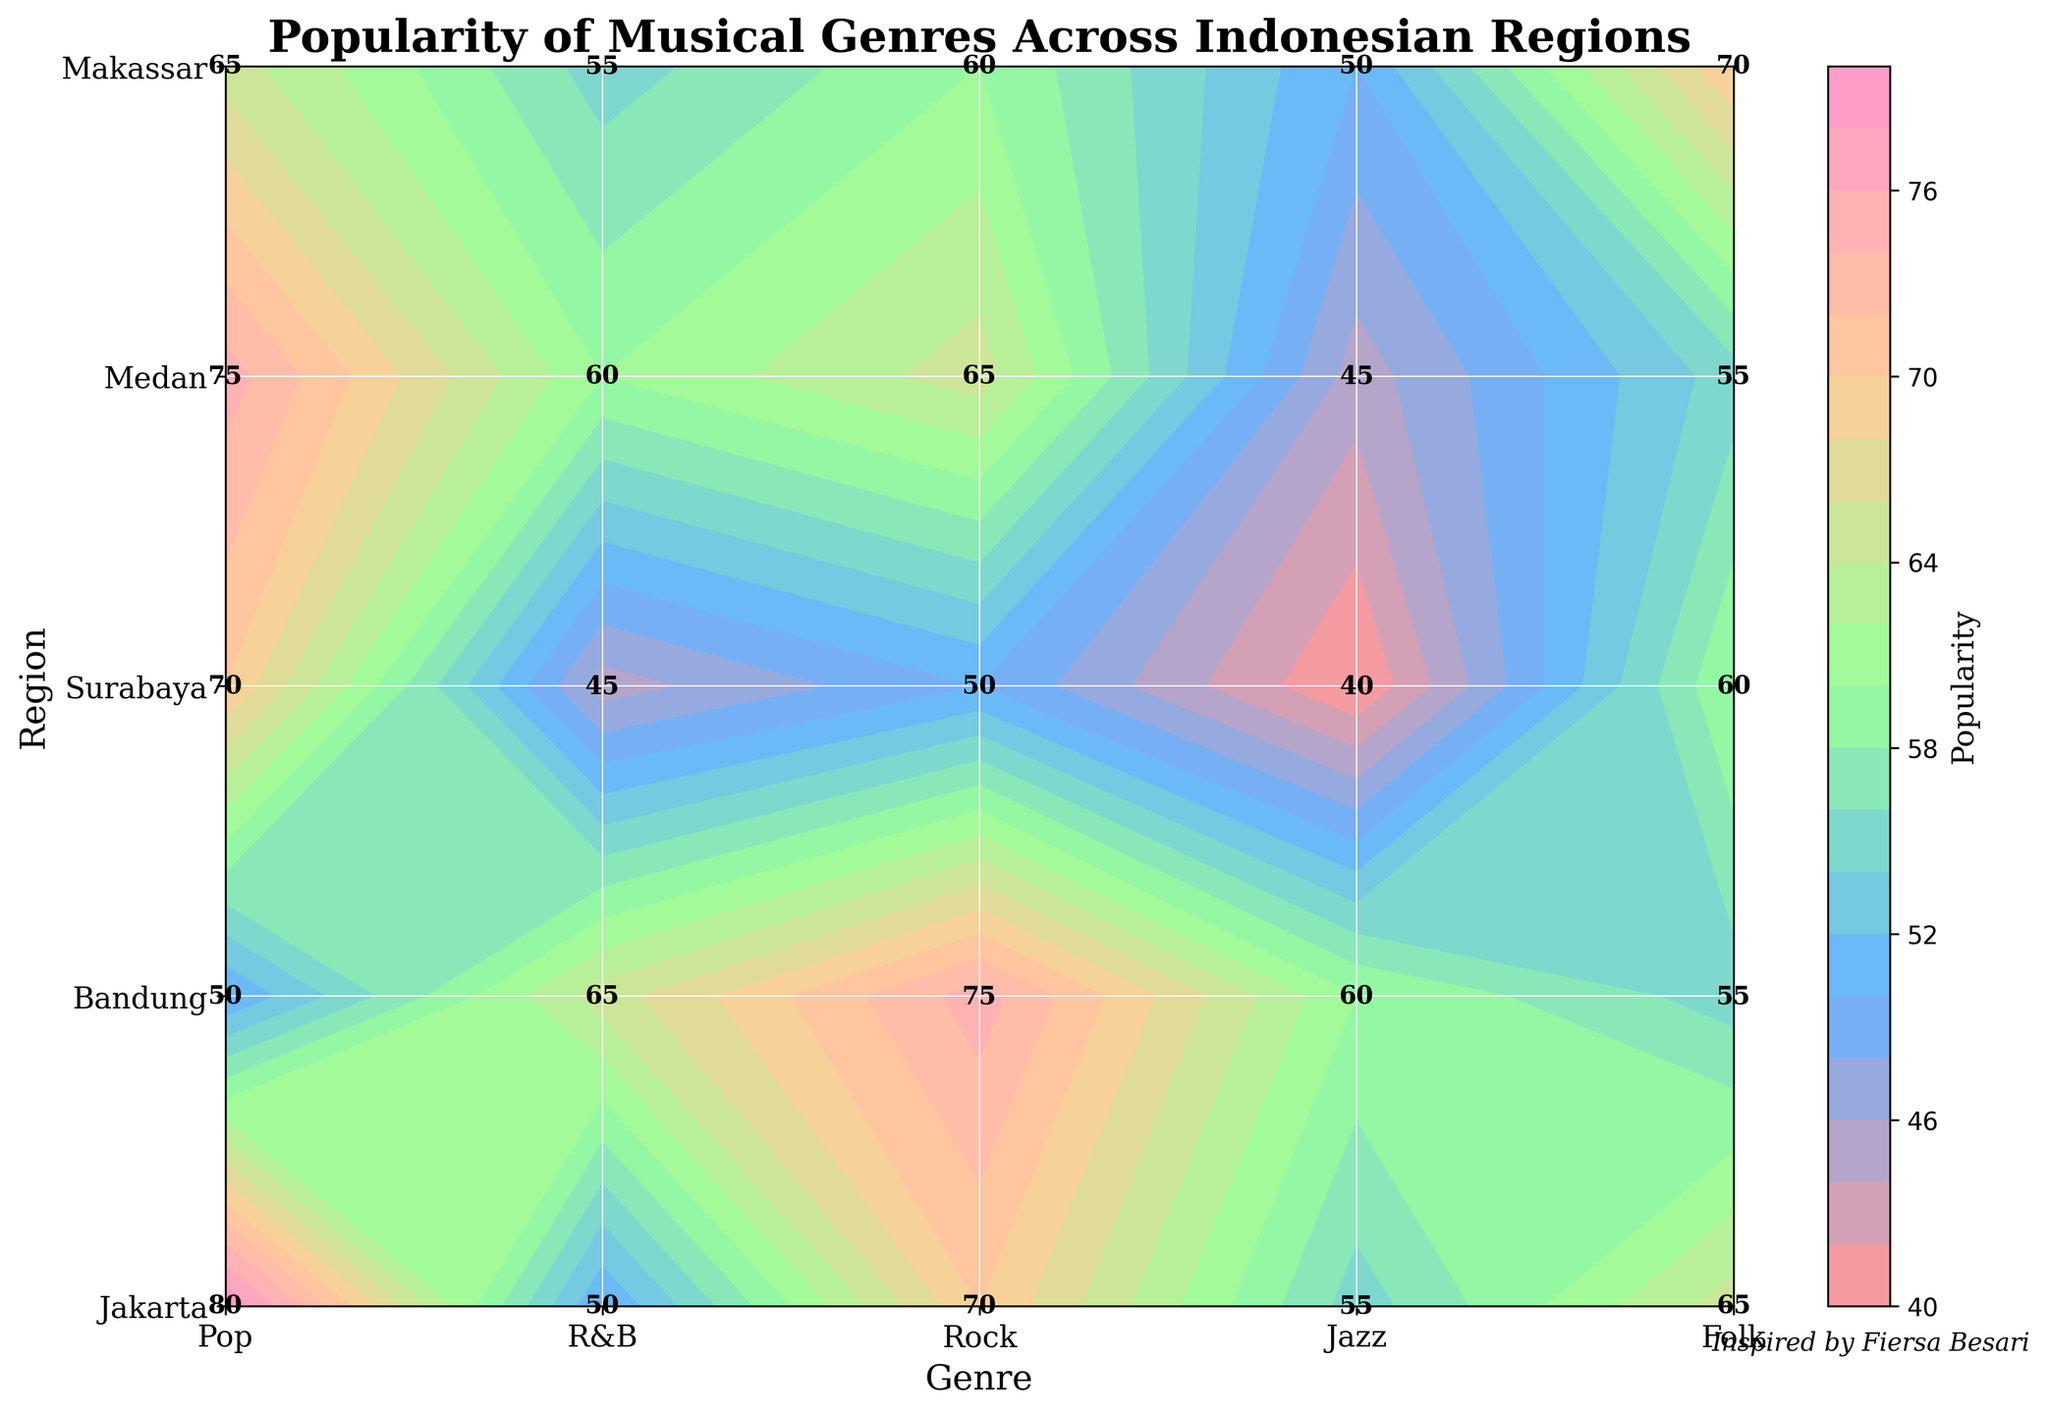What's the title of the plot? The title of the plot is usually placed at the top of the figure. By looking at the top of this plot, we see the title "Popularity of Musical Genres Across Indonesian Regions."
Answer: Popularity of Musical Genres Across Indonesian Regions Which genre is the most popular in Bandung? To find the most popular genre in Bandung, we need to look at the values for each genre in Bandung and identify the highest number. The highest popularity value in Bandung is for Folk music, which is 80.
Answer: Folk What is the popularity difference of Pop music between Jakarta and Makassar? To calculate the popularity difference, we need the Pop music values from both Jakarta and Makassar. In Jakarta, Pop is 75, and in Makassar, Pop is 50. The difference is 75 - 50.
Answer: 25 Which region has the least popularity for R&B music? By looking at the R&B column and identifying the lowest value among all regions, we see that Makassar has the least popularity for R&B music with a value of 40.
Answer: Makassar Which genre shows the highest popularity in Surabaya? To find the highest popularity genre in Surabaya, compare the values of each genre. The highest value is for Rock music, which is 70.
Answer: Rock What is the average popularity of Folk music across all regions? To find the average popularity of Folk music, sum the values across all regions and divide by the number of regions. The values are 50 (Jakarta), 80 (Bandung), 65 (Surabaya), 75 (Medan), and 70 (Makassar). Sum is 50 + 80 + 65 + 75 + 70 = 340. The number of regions is 5. So, the average is 340 / 5.
Answer: 68 Is Rock music more popular in Surabaya or Medan? Compare the popularity values of Rock music between the two regions. Surabaya's value is 70, and Medan's is 55.
Answer: Surabaya What is the overall trend of Pop music popularity from Jakarta to Makassar? Examine the Pop music values across the regions in order: Jakarta (75), Bandung (70), Surabaya (60), Medan (65), Makassar (50). The trend shows a general decrease from Jakarta to Makassar.
Answer: Decreasing 